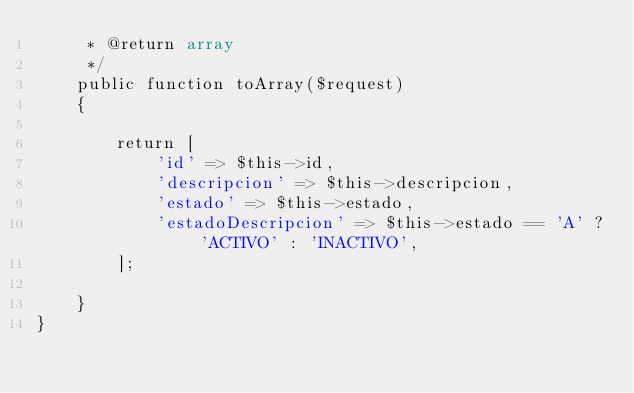Convert code to text. <code><loc_0><loc_0><loc_500><loc_500><_PHP_>     * @return array
     */
    public function toArray($request)
    {   
       
        return [
            'id' => $this->id,
            'descripcion' => $this->descripcion,
            'estado' => $this->estado,
            'estadoDescripcion' => $this->estado == 'A' ? 'ACTIVO' : 'INACTIVO',
        ];

    }
}</code> 